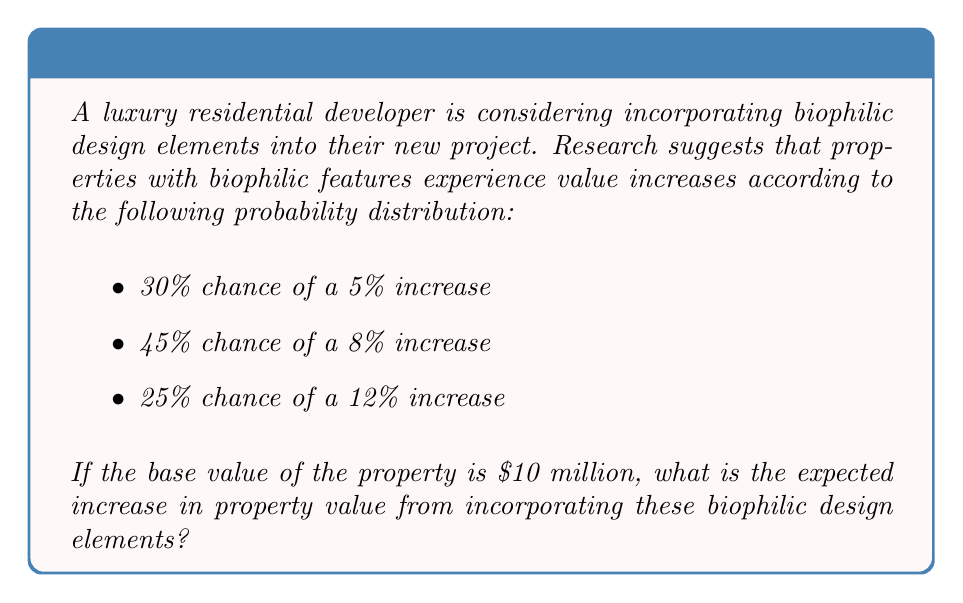Teach me how to tackle this problem. To solve this problem, we'll use the concept of expected value. The expected value is calculated by multiplying each possible outcome by its probability and then summing these products.

Let's break it down step-by-step:

1) First, let's calculate the value increase for each scenario:
   
   5% of $10 million: $10,000,000 * 0.05 = $500,000
   8% of $10 million: $10,000,000 * 0.08 = $800,000
   12% of $10 million: $10,000,000 * 0.12 = $1,200,000

2) Now, let's set up the expected value equation:

   $$ E(X) = (500,000 * 0.30) + (800,000 * 0.45) + (1,200,000 * 0.25) $$

3) Let's calculate each term:
   
   $500,000 * 0.30 = 150,000$
   $800,000 * 0.45 = 360,000$
   $1,200,000 * 0.25 = 300,000$

4) Now, sum these values:

   $$ E(X) = 150,000 + 360,000 + 300,000 = 810,000 $$

Therefore, the expected increase in property value from incorporating biophilic design elements is $810,000.
Answer: $810,000 